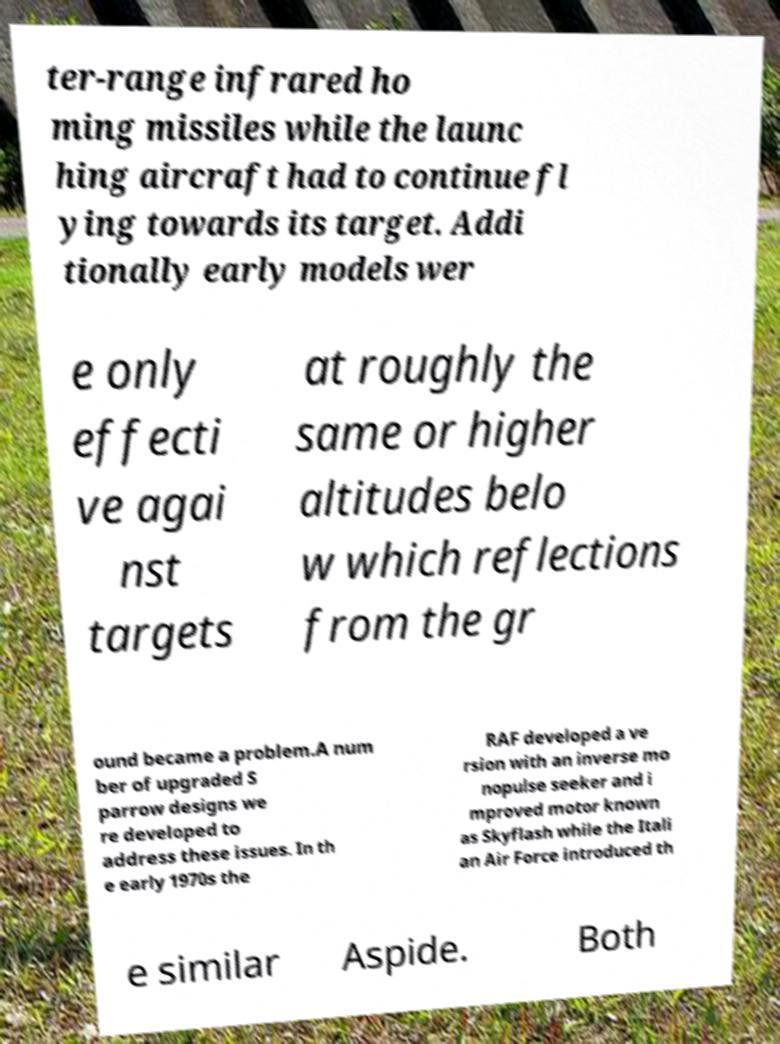Can you accurately transcribe the text from the provided image for me? ter-range infrared ho ming missiles while the launc hing aircraft had to continue fl ying towards its target. Addi tionally early models wer e only effecti ve agai nst targets at roughly the same or higher altitudes belo w which reflections from the gr ound became a problem.A num ber of upgraded S parrow designs we re developed to address these issues. In th e early 1970s the RAF developed a ve rsion with an inverse mo nopulse seeker and i mproved motor known as Skyflash while the Itali an Air Force introduced th e similar Aspide. Both 